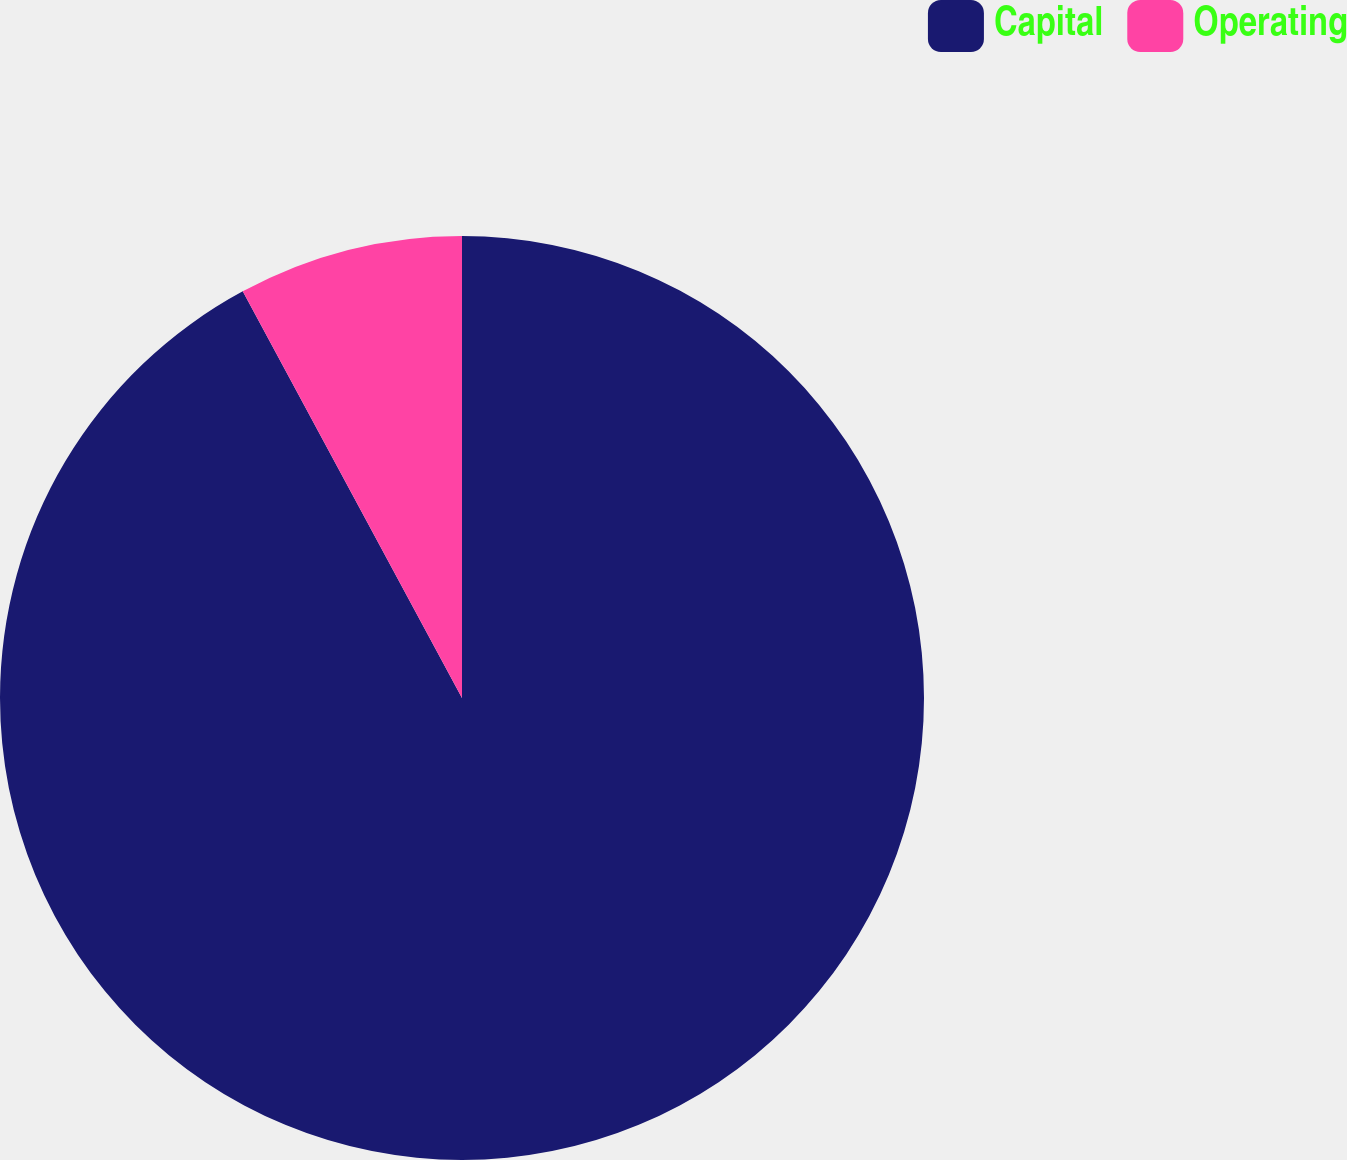Convert chart. <chart><loc_0><loc_0><loc_500><loc_500><pie_chart><fcel>Capital<fcel>Operating<nl><fcel>92.13%<fcel>7.87%<nl></chart> 